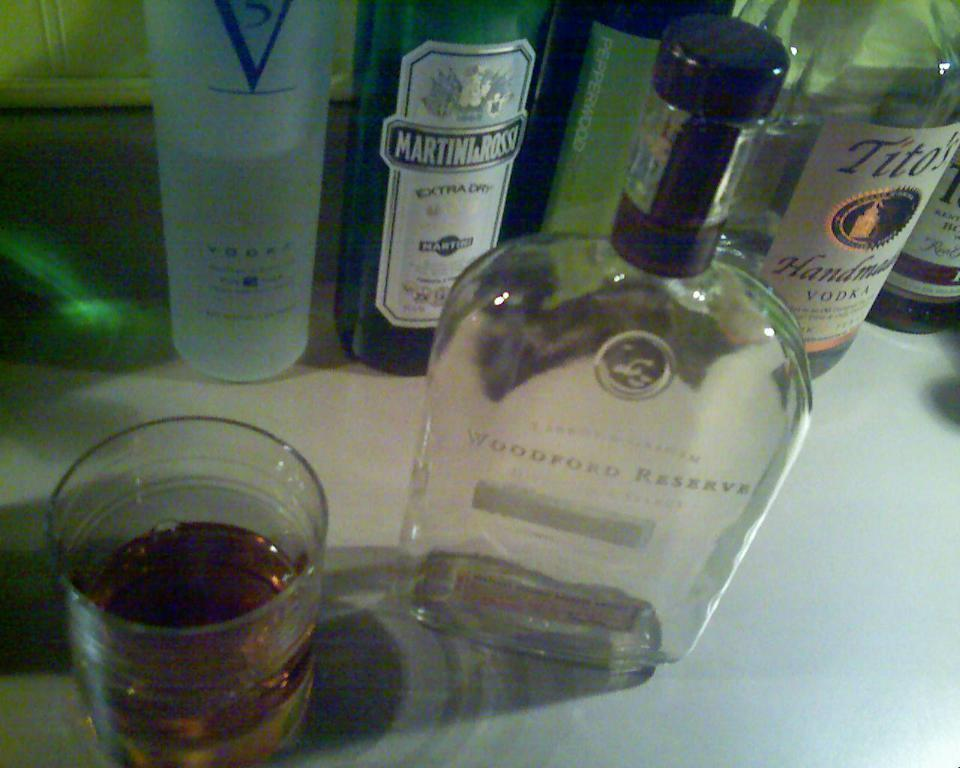<image>
Provide a brief description of the given image. An empty bottle of Woodford Reserve among other liquor bottles. 